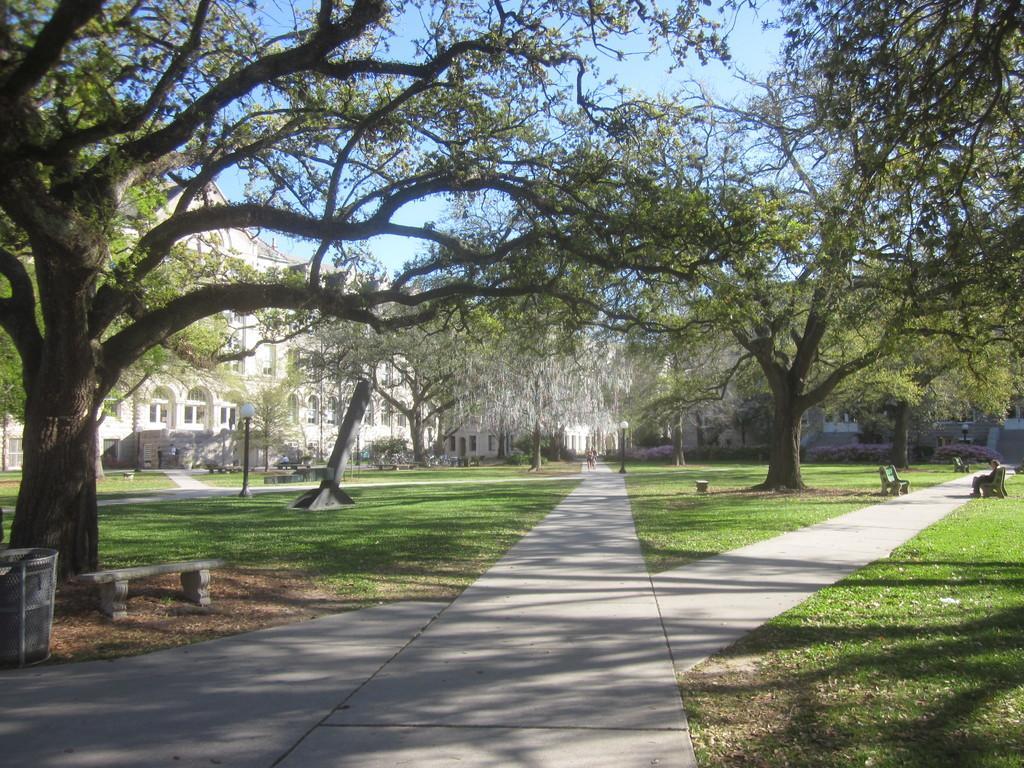Please provide a concise description of this image. This image is clicked outside. At the bottom, there is a path. In the front, there are trees. In the background, we can see the buildings. At the bottom, there is green grass on the ground. On the left, there is a dustbin. 